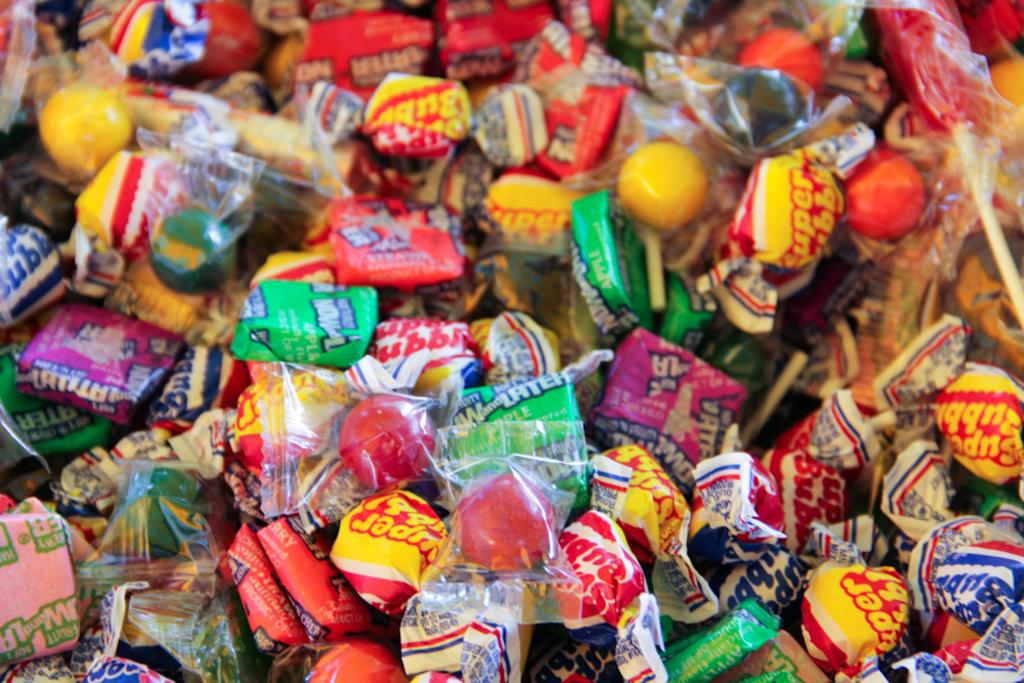What type of food can be seen in the image? There are candies in the image. What type of friend can be seen in the image? There is no friend present in the image; it only features candies. What type of iron is visible in the image? There is no iron present in the image; it only features candies. 